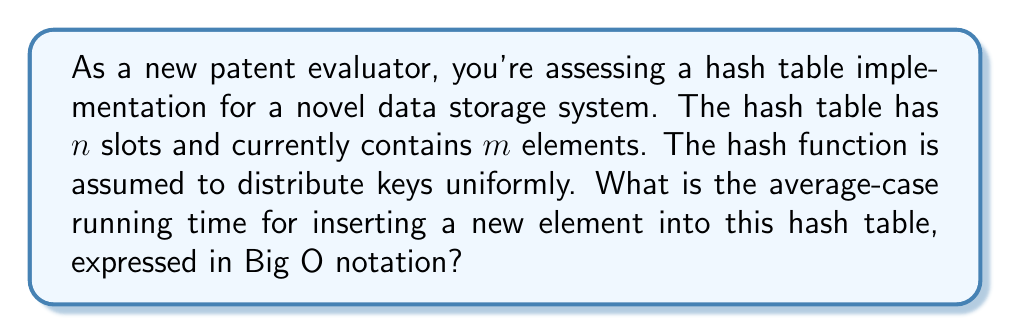Show me your answer to this math problem. To understand the average-case running time for inserting an element into a hash table, let's break down the process:

1) First, we need to calculate the load factor $\alpha$ of the hash table:
   $$ \alpha = \frac{m}{n} $$
   where $m$ is the number of elements and $n$ is the number of slots.

2) In an ideal scenario with perfect hashing, each insertion would take $O(1)$ time. However, collisions can occur, leading to longer insertion times.

3) The probability of a collision occurring when inserting a new element is approximately equal to the load factor $\alpha$.

4) If a collision occurs, we need to handle it. Common methods include:
   - Chaining: where we add the new element to a linked list at the collided slot
   - Open addressing: where we probe for the next available slot

5) For this analysis, let's assume chaining is used. The average length of each chain is equal to the load factor $\alpha$.

6) Therefore, when inserting a new element:
   - With probability $(1 - \alpha)$, we insert directly with $O(1)$ time
   - With probability $\alpha$, we need to traverse an average of $\alpha$ elements

7) The expected time for insertion can be expressed as:
   $$ E[T] = (1 - \alpha) \cdot O(1) + \alpha \cdot O(\alpha) = O(1) + O(\alpha^2) $$

8) Simplifying, we get:
   $$ E[T] = O(1 + \alpha) $$

9) In the average case, we assume the load factor is kept constant (usually around 0.75) through dynamic resizing of the hash table. Thus, $\alpha$ is treated as a constant.

10) Therefore, the average-case time complexity simplifies to $O(1)$.

This constant-time average performance is what makes hash tables so efficient for many applications, including those you might encounter in patent evaluations for data storage systems.
Answer: $O(1)$ 